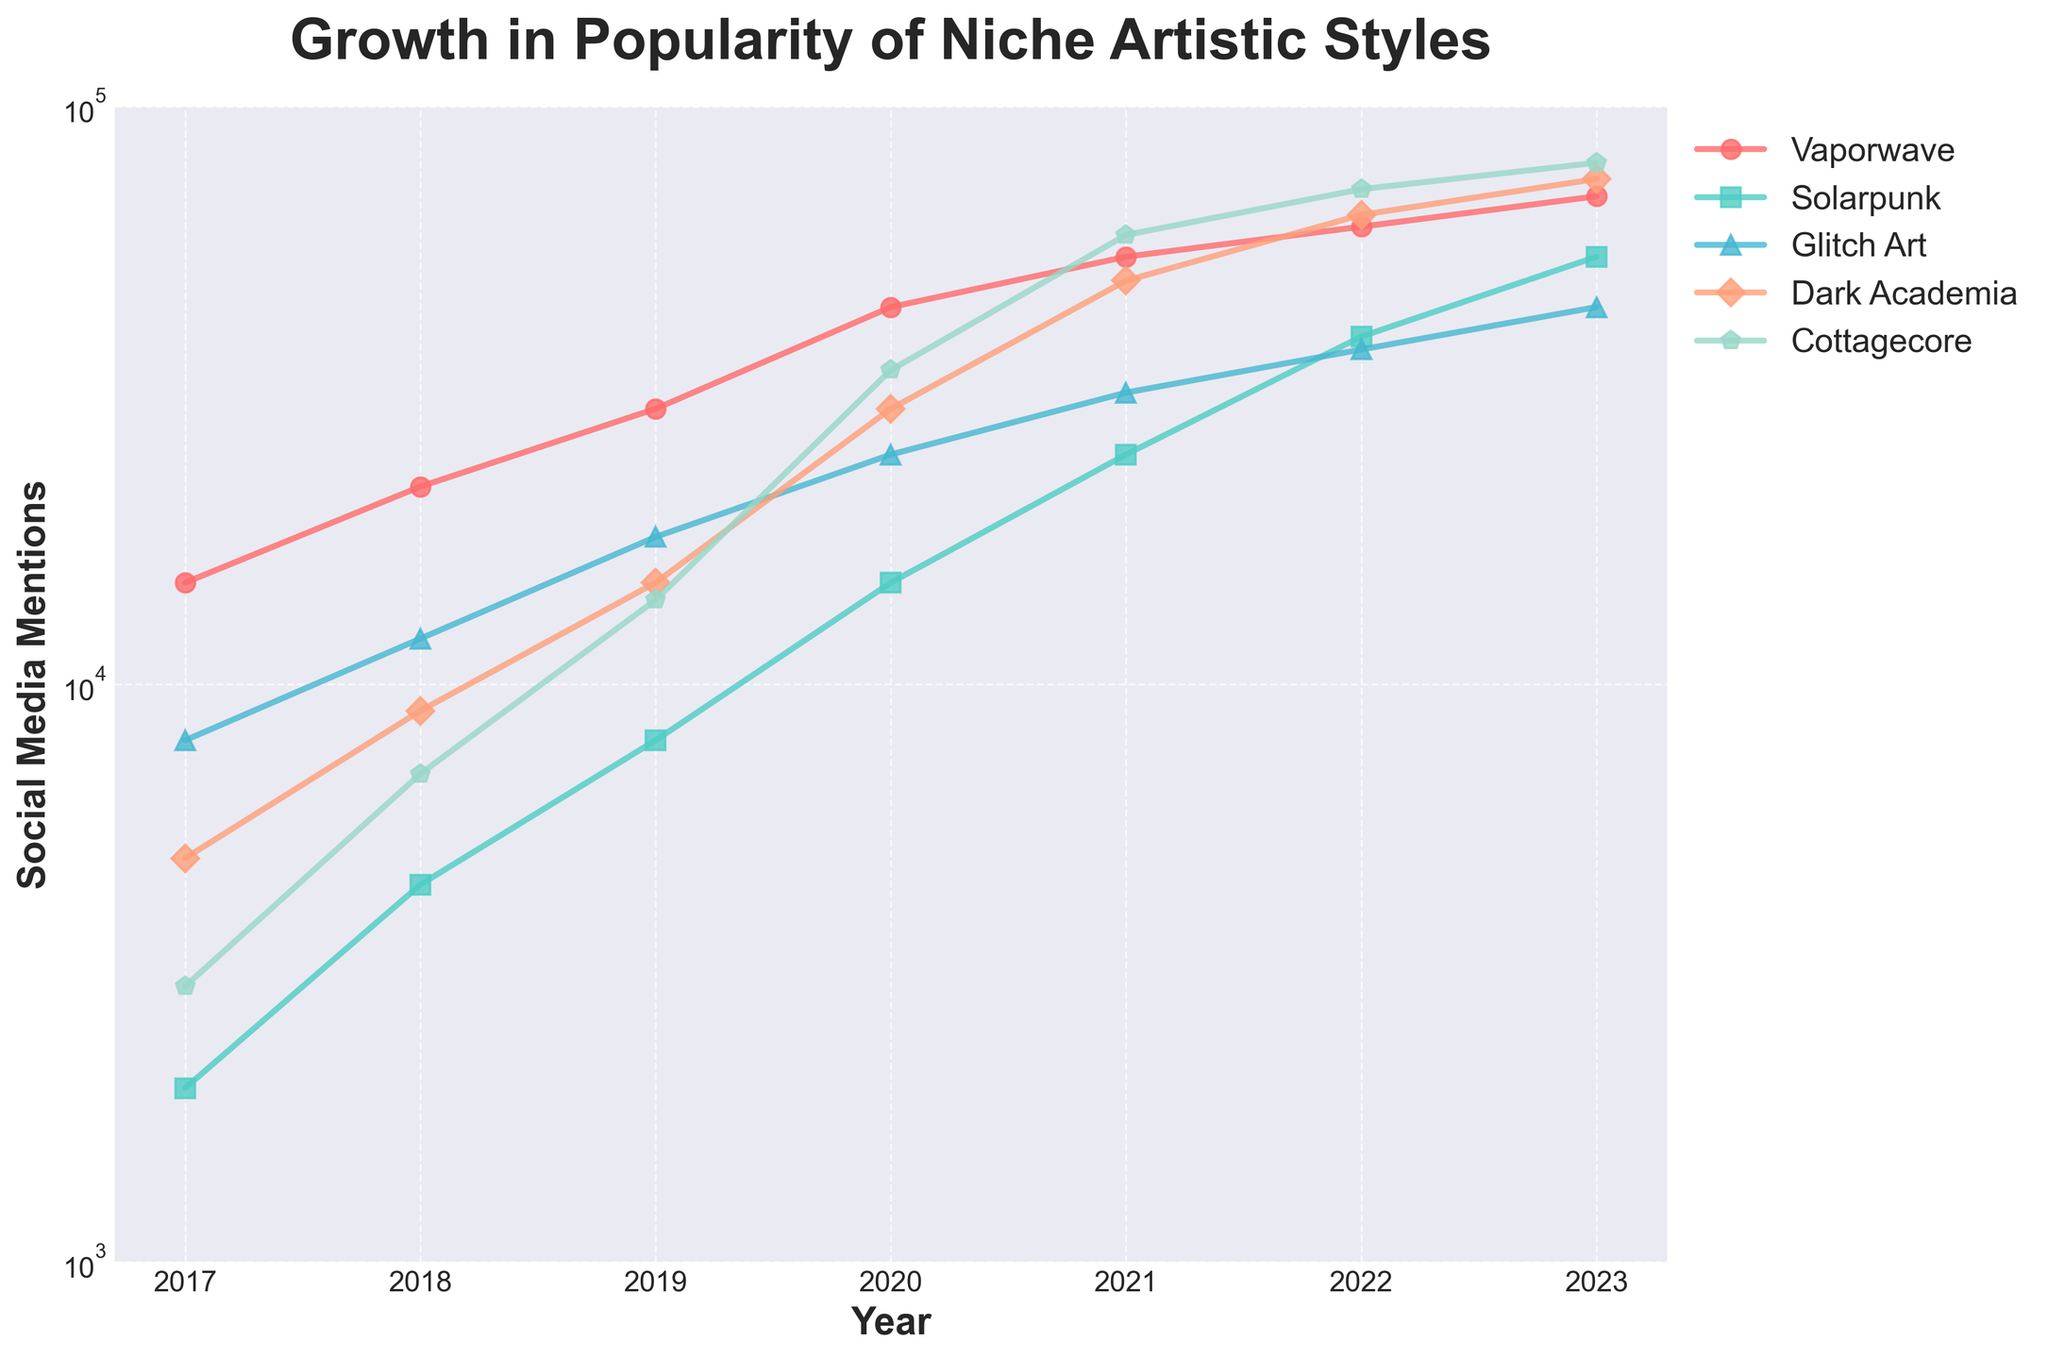Which artistic style had the highest number of social media mentions in 2023? Look at the values for each artistic style in 2023 and identify the highest value, which belongs to Dark Academia with 75,000 mentions.
Answer: Dark Academia What is the difference in social media mentions between Cottagecore and Solarpunk in 2022? Subtract the number of Solarpunk mentions from Cottagecore mentions for 2022. Cottagecore had 72,000 mentions and Solarpunk had 40,000 mentions, so the difference is 72,000 - 40,000 = 32,000.
Answer: 32,000 Which artistic style showed the greatest increase in mentions from 2020 to 2021? Calculate the increase for each style from 2020 to 2021 and compare them. Vaporwave: 55,000 - 45,000 = 10,000, Solarpunk: 25,000 - 15,000 = 10,000, Glitch Art: 32,000 - 25,000 = 7,000, Dark Academia: 50,000 - 30,000 = 20,000, Cottagecore: 60,000 - 35,000 = 25,000. Cottagecore has the greatest increase of 25,000 mentions.
Answer: Cottagecore What is the average number of mentions for Dark Academia from 2017 to 2023? Add the number of mentions for each year from 2017 to 2023, then divide by the number of years. (5,000+9,000+15,000+30,000+50,000+65,000+75,000) = 249,000, so the average is 249,000 / 7 = 35,571.43
Answer: 35,571.43 How did the popularity of Vaporwave change from 2017 to 2023? Compare the number of mentions in 2017 and 2023 for Vaporwave. In 2017, Vaporwave had 15,000 mentions and in 2023 it had 70,000 mentions. The increase is 70,000 - 15,000 = 55,000, indicating a significant rise in popularity.
Answer: Increased by 55,000 Which artistic style had the slowest growth in social media mentions over the entire period? Calculate the total increase from 2017 to 2023 for each style. Vaporwave: (70,000 - 15,000) = 55,000, Solarpunk: (55,000 - 2,000) = 53,000, Glitch Art: (45,000 - 8,000) = 37,000, Dark Academia: (75,000 - 5,000) = 70,000, Cottagecore: (80,000 - 3,000) = 77,000. Glitch Art had the slowest growth of 37,000 mentions.
Answer: Glitch Art What was the total number of social media mentions for all artistic styles combined in 2019? Add the number of mentions for all artistic styles in 2019. 30,000 (Vaporwave) + 8,000 (Solarpunk) + 18,000 (Glitch Art) + 15,000 (Dark Academia) + 14,000 (Cottagecore) = 85,000.
Answer: 85,000 Which artistic style had the highest increase in mentions from 2021 to 2022? Calculate the increase for each style from 2021 to 2022 and compare them. Vaporwave: (62,000 - 55,000) = 7,000, Solarpunk: (40,000 - 25,000) = 15,000, Glitch Art: (38,000 - 32,000) = 6,000, Dark Academia: (65,000 - 50,000) = 15,000, Cottagecore: (72,000 - 60,000) = 12,000. Both Solarpunk and Dark Academia had the highest increase with 15,000 mentions each.
Answer: Solarpunk and Dark Academia 